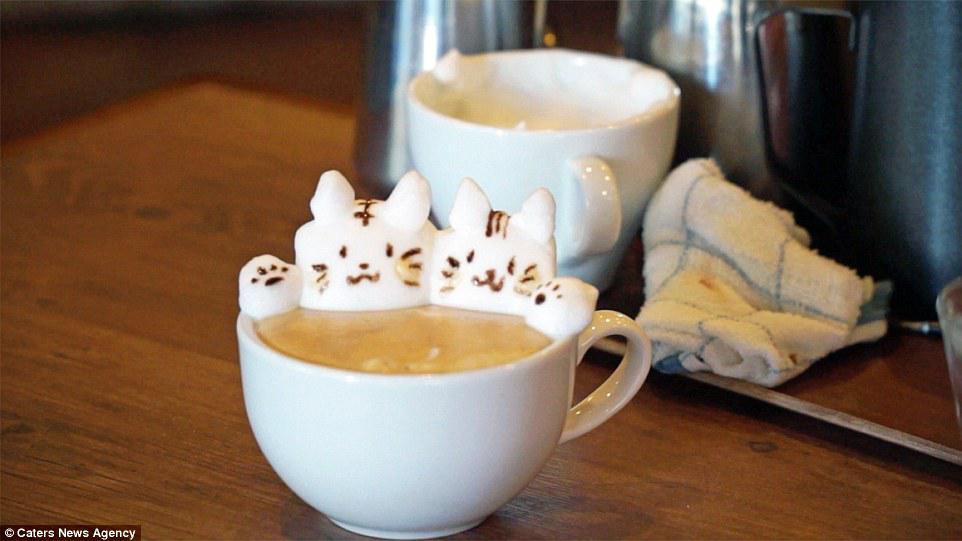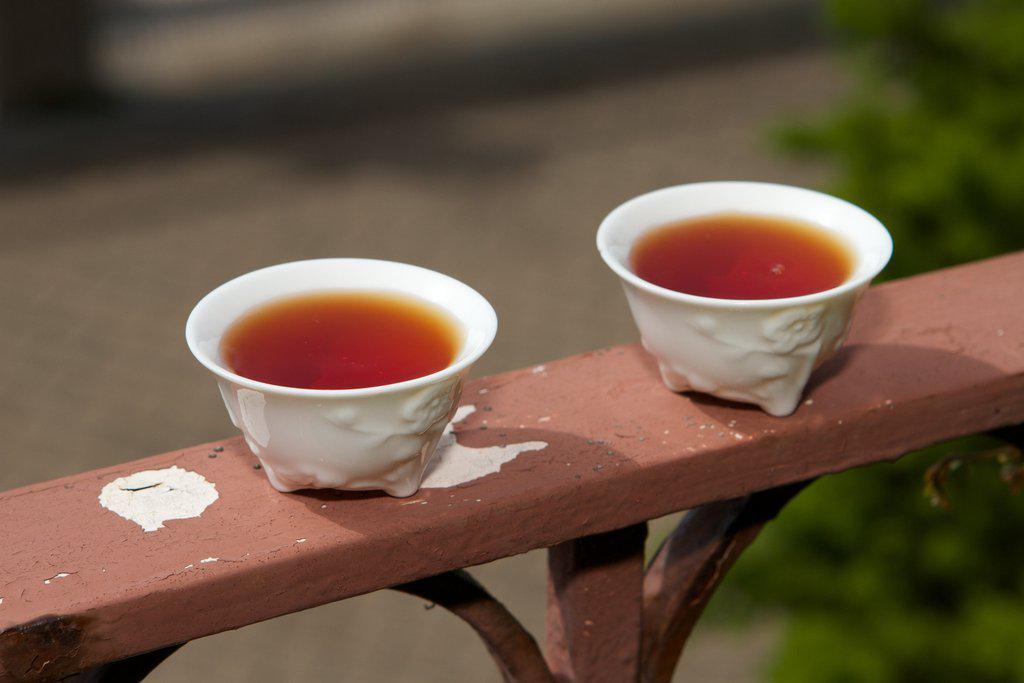The first image is the image on the left, the second image is the image on the right. For the images shown, is this caption "There are four cups of hot drinks, and two of them are sitting on plates." true? Answer yes or no. No. The first image is the image on the left, the second image is the image on the right. Evaluate the accuracy of this statement regarding the images: "The pair of cups in the right image have no handles.". Is it true? Answer yes or no. Yes. 